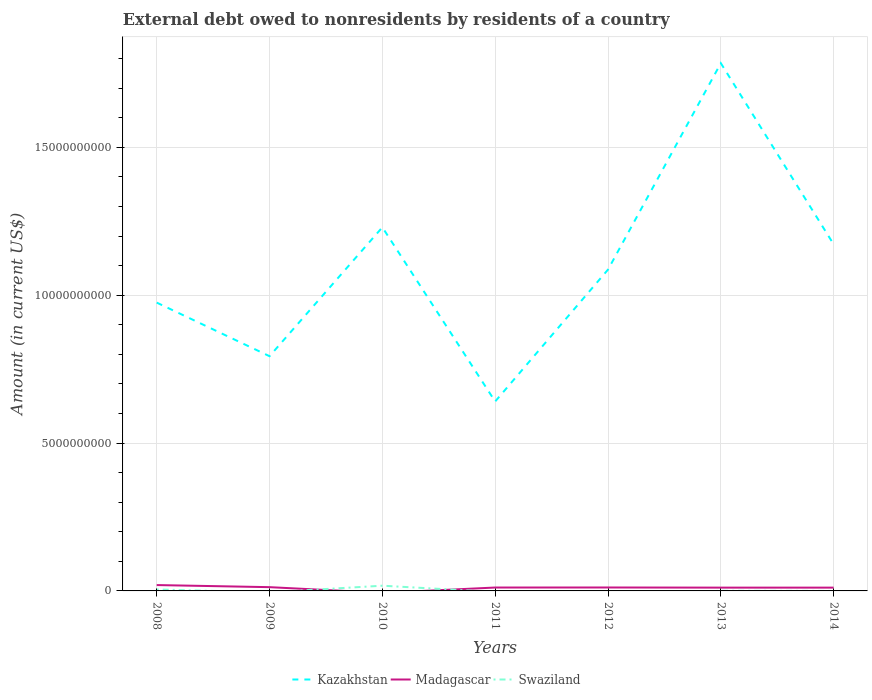Is the number of lines equal to the number of legend labels?
Give a very brief answer. No. Across all years, what is the maximum external debt owed by residents in Swaziland?
Make the answer very short. 0. What is the total external debt owed by residents in Kazakhstan in the graph?
Provide a short and direct response. -2.55e+09. What is the difference between the highest and the second highest external debt owed by residents in Madagascar?
Your response must be concise. 1.98e+08. Is the external debt owed by residents in Madagascar strictly greater than the external debt owed by residents in Kazakhstan over the years?
Your answer should be compact. Yes. How many lines are there?
Make the answer very short. 3. How many years are there in the graph?
Offer a very short reply. 7. Does the graph contain grids?
Your answer should be very brief. Yes. Where does the legend appear in the graph?
Provide a short and direct response. Bottom center. How many legend labels are there?
Your answer should be compact. 3. What is the title of the graph?
Make the answer very short. External debt owed to nonresidents by residents of a country. Does "Central African Republic" appear as one of the legend labels in the graph?
Offer a terse response. No. What is the label or title of the Y-axis?
Provide a succinct answer. Amount (in current US$). What is the Amount (in current US$) in Kazakhstan in 2008?
Give a very brief answer. 9.75e+09. What is the Amount (in current US$) in Madagascar in 2008?
Make the answer very short. 1.98e+08. What is the Amount (in current US$) of Swaziland in 2008?
Offer a very short reply. 4.91e+07. What is the Amount (in current US$) in Kazakhstan in 2009?
Ensure brevity in your answer.  7.94e+09. What is the Amount (in current US$) of Madagascar in 2009?
Your answer should be very brief. 1.27e+08. What is the Amount (in current US$) of Swaziland in 2009?
Your answer should be very brief. 0. What is the Amount (in current US$) of Kazakhstan in 2010?
Provide a short and direct response. 1.23e+1. What is the Amount (in current US$) of Madagascar in 2010?
Your answer should be compact. 0. What is the Amount (in current US$) in Swaziland in 2010?
Make the answer very short. 1.77e+08. What is the Amount (in current US$) of Kazakhstan in 2011?
Offer a very short reply. 6.41e+09. What is the Amount (in current US$) of Madagascar in 2011?
Your answer should be compact. 1.15e+08. What is the Amount (in current US$) of Swaziland in 2011?
Give a very brief answer. 0. What is the Amount (in current US$) of Kazakhstan in 2012?
Your answer should be compact. 1.09e+1. What is the Amount (in current US$) in Madagascar in 2012?
Ensure brevity in your answer.  1.16e+08. What is the Amount (in current US$) in Swaziland in 2012?
Offer a very short reply. 0. What is the Amount (in current US$) in Kazakhstan in 2013?
Offer a terse response. 1.78e+1. What is the Amount (in current US$) in Madagascar in 2013?
Your answer should be compact. 1.12e+08. What is the Amount (in current US$) in Swaziland in 2013?
Offer a very short reply. 4.84e+06. What is the Amount (in current US$) in Kazakhstan in 2014?
Keep it short and to the point. 1.17e+1. What is the Amount (in current US$) in Madagascar in 2014?
Provide a short and direct response. 1.12e+08. What is the Amount (in current US$) of Swaziland in 2014?
Give a very brief answer. 0. Across all years, what is the maximum Amount (in current US$) in Kazakhstan?
Offer a very short reply. 1.78e+1. Across all years, what is the maximum Amount (in current US$) of Madagascar?
Provide a short and direct response. 1.98e+08. Across all years, what is the maximum Amount (in current US$) of Swaziland?
Your response must be concise. 1.77e+08. Across all years, what is the minimum Amount (in current US$) in Kazakhstan?
Ensure brevity in your answer.  6.41e+09. Across all years, what is the minimum Amount (in current US$) in Madagascar?
Provide a succinct answer. 0. What is the total Amount (in current US$) of Kazakhstan in the graph?
Offer a terse response. 7.68e+1. What is the total Amount (in current US$) in Madagascar in the graph?
Keep it short and to the point. 7.80e+08. What is the total Amount (in current US$) of Swaziland in the graph?
Offer a very short reply. 2.31e+08. What is the difference between the Amount (in current US$) in Kazakhstan in 2008 and that in 2009?
Your answer should be very brief. 1.81e+09. What is the difference between the Amount (in current US$) of Madagascar in 2008 and that in 2009?
Provide a short and direct response. 7.08e+07. What is the difference between the Amount (in current US$) in Kazakhstan in 2008 and that in 2010?
Your answer should be very brief. -2.55e+09. What is the difference between the Amount (in current US$) of Swaziland in 2008 and that in 2010?
Your answer should be compact. -1.28e+08. What is the difference between the Amount (in current US$) in Kazakhstan in 2008 and that in 2011?
Offer a terse response. 3.34e+09. What is the difference between the Amount (in current US$) of Madagascar in 2008 and that in 2011?
Give a very brief answer. 8.37e+07. What is the difference between the Amount (in current US$) in Kazakhstan in 2008 and that in 2012?
Keep it short and to the point. -1.12e+09. What is the difference between the Amount (in current US$) of Madagascar in 2008 and that in 2012?
Provide a short and direct response. 8.20e+07. What is the difference between the Amount (in current US$) of Kazakhstan in 2008 and that in 2013?
Provide a short and direct response. -8.09e+09. What is the difference between the Amount (in current US$) in Madagascar in 2008 and that in 2013?
Your response must be concise. 8.67e+07. What is the difference between the Amount (in current US$) in Swaziland in 2008 and that in 2013?
Provide a succinct answer. 4.43e+07. What is the difference between the Amount (in current US$) in Kazakhstan in 2008 and that in 2014?
Keep it short and to the point. -1.97e+09. What is the difference between the Amount (in current US$) of Madagascar in 2008 and that in 2014?
Offer a very short reply. 8.66e+07. What is the difference between the Amount (in current US$) of Kazakhstan in 2009 and that in 2010?
Your answer should be compact. -4.36e+09. What is the difference between the Amount (in current US$) in Kazakhstan in 2009 and that in 2011?
Make the answer very short. 1.53e+09. What is the difference between the Amount (in current US$) in Madagascar in 2009 and that in 2011?
Ensure brevity in your answer.  1.29e+07. What is the difference between the Amount (in current US$) in Kazakhstan in 2009 and that in 2012?
Your answer should be very brief. -2.93e+09. What is the difference between the Amount (in current US$) in Madagascar in 2009 and that in 2012?
Give a very brief answer. 1.12e+07. What is the difference between the Amount (in current US$) in Kazakhstan in 2009 and that in 2013?
Make the answer very short. -9.91e+09. What is the difference between the Amount (in current US$) in Madagascar in 2009 and that in 2013?
Provide a short and direct response. 1.59e+07. What is the difference between the Amount (in current US$) of Kazakhstan in 2009 and that in 2014?
Provide a succinct answer. -3.78e+09. What is the difference between the Amount (in current US$) of Madagascar in 2009 and that in 2014?
Provide a short and direct response. 1.58e+07. What is the difference between the Amount (in current US$) of Kazakhstan in 2010 and that in 2011?
Offer a terse response. 5.89e+09. What is the difference between the Amount (in current US$) of Kazakhstan in 2010 and that in 2012?
Keep it short and to the point. 1.43e+09. What is the difference between the Amount (in current US$) in Kazakhstan in 2010 and that in 2013?
Give a very brief answer. -5.55e+09. What is the difference between the Amount (in current US$) in Swaziland in 2010 and that in 2013?
Give a very brief answer. 1.72e+08. What is the difference between the Amount (in current US$) of Kazakhstan in 2010 and that in 2014?
Provide a short and direct response. 5.75e+08. What is the difference between the Amount (in current US$) in Kazakhstan in 2011 and that in 2012?
Keep it short and to the point. -4.46e+09. What is the difference between the Amount (in current US$) in Madagascar in 2011 and that in 2012?
Make the answer very short. -1.68e+06. What is the difference between the Amount (in current US$) in Kazakhstan in 2011 and that in 2013?
Your answer should be compact. -1.14e+1. What is the difference between the Amount (in current US$) in Madagascar in 2011 and that in 2013?
Your answer should be compact. 2.99e+06. What is the difference between the Amount (in current US$) of Kazakhstan in 2011 and that in 2014?
Give a very brief answer. -5.31e+09. What is the difference between the Amount (in current US$) of Madagascar in 2011 and that in 2014?
Give a very brief answer. 2.89e+06. What is the difference between the Amount (in current US$) of Kazakhstan in 2012 and that in 2013?
Your response must be concise. -6.98e+09. What is the difference between the Amount (in current US$) in Madagascar in 2012 and that in 2013?
Your answer should be very brief. 4.67e+06. What is the difference between the Amount (in current US$) in Kazakhstan in 2012 and that in 2014?
Provide a succinct answer. -8.55e+08. What is the difference between the Amount (in current US$) in Madagascar in 2012 and that in 2014?
Your answer should be compact. 4.57e+06. What is the difference between the Amount (in current US$) of Kazakhstan in 2013 and that in 2014?
Make the answer very short. 6.12e+09. What is the difference between the Amount (in current US$) of Madagascar in 2013 and that in 2014?
Offer a terse response. -9.90e+04. What is the difference between the Amount (in current US$) of Kazakhstan in 2008 and the Amount (in current US$) of Madagascar in 2009?
Your response must be concise. 9.62e+09. What is the difference between the Amount (in current US$) in Kazakhstan in 2008 and the Amount (in current US$) in Swaziland in 2010?
Keep it short and to the point. 9.57e+09. What is the difference between the Amount (in current US$) in Madagascar in 2008 and the Amount (in current US$) in Swaziland in 2010?
Offer a terse response. 2.16e+07. What is the difference between the Amount (in current US$) of Kazakhstan in 2008 and the Amount (in current US$) of Madagascar in 2011?
Your response must be concise. 9.63e+09. What is the difference between the Amount (in current US$) of Kazakhstan in 2008 and the Amount (in current US$) of Madagascar in 2012?
Your response must be concise. 9.63e+09. What is the difference between the Amount (in current US$) in Kazakhstan in 2008 and the Amount (in current US$) in Madagascar in 2013?
Keep it short and to the point. 9.64e+09. What is the difference between the Amount (in current US$) of Kazakhstan in 2008 and the Amount (in current US$) of Swaziland in 2013?
Give a very brief answer. 9.74e+09. What is the difference between the Amount (in current US$) of Madagascar in 2008 and the Amount (in current US$) of Swaziland in 2013?
Provide a succinct answer. 1.93e+08. What is the difference between the Amount (in current US$) in Kazakhstan in 2008 and the Amount (in current US$) in Madagascar in 2014?
Provide a short and direct response. 9.64e+09. What is the difference between the Amount (in current US$) of Kazakhstan in 2009 and the Amount (in current US$) of Swaziland in 2010?
Make the answer very short. 7.76e+09. What is the difference between the Amount (in current US$) of Madagascar in 2009 and the Amount (in current US$) of Swaziland in 2010?
Offer a very short reply. -4.92e+07. What is the difference between the Amount (in current US$) of Kazakhstan in 2009 and the Amount (in current US$) of Madagascar in 2011?
Offer a terse response. 7.82e+09. What is the difference between the Amount (in current US$) of Kazakhstan in 2009 and the Amount (in current US$) of Madagascar in 2012?
Your response must be concise. 7.82e+09. What is the difference between the Amount (in current US$) in Kazakhstan in 2009 and the Amount (in current US$) in Madagascar in 2013?
Give a very brief answer. 7.83e+09. What is the difference between the Amount (in current US$) in Kazakhstan in 2009 and the Amount (in current US$) in Swaziland in 2013?
Make the answer very short. 7.93e+09. What is the difference between the Amount (in current US$) in Madagascar in 2009 and the Amount (in current US$) in Swaziland in 2013?
Offer a terse response. 1.23e+08. What is the difference between the Amount (in current US$) in Kazakhstan in 2009 and the Amount (in current US$) in Madagascar in 2014?
Give a very brief answer. 7.82e+09. What is the difference between the Amount (in current US$) of Kazakhstan in 2010 and the Amount (in current US$) of Madagascar in 2011?
Give a very brief answer. 1.22e+1. What is the difference between the Amount (in current US$) in Kazakhstan in 2010 and the Amount (in current US$) in Madagascar in 2012?
Offer a very short reply. 1.22e+1. What is the difference between the Amount (in current US$) in Kazakhstan in 2010 and the Amount (in current US$) in Madagascar in 2013?
Give a very brief answer. 1.22e+1. What is the difference between the Amount (in current US$) of Kazakhstan in 2010 and the Amount (in current US$) of Swaziland in 2013?
Provide a succinct answer. 1.23e+1. What is the difference between the Amount (in current US$) in Kazakhstan in 2010 and the Amount (in current US$) in Madagascar in 2014?
Offer a very short reply. 1.22e+1. What is the difference between the Amount (in current US$) in Kazakhstan in 2011 and the Amount (in current US$) in Madagascar in 2012?
Your answer should be compact. 6.29e+09. What is the difference between the Amount (in current US$) in Kazakhstan in 2011 and the Amount (in current US$) in Madagascar in 2013?
Your answer should be very brief. 6.29e+09. What is the difference between the Amount (in current US$) of Kazakhstan in 2011 and the Amount (in current US$) of Swaziland in 2013?
Provide a succinct answer. 6.40e+09. What is the difference between the Amount (in current US$) of Madagascar in 2011 and the Amount (in current US$) of Swaziland in 2013?
Your answer should be very brief. 1.10e+08. What is the difference between the Amount (in current US$) in Kazakhstan in 2011 and the Amount (in current US$) in Madagascar in 2014?
Provide a succinct answer. 6.29e+09. What is the difference between the Amount (in current US$) of Kazakhstan in 2012 and the Amount (in current US$) of Madagascar in 2013?
Your answer should be compact. 1.08e+1. What is the difference between the Amount (in current US$) in Kazakhstan in 2012 and the Amount (in current US$) in Swaziland in 2013?
Provide a succinct answer. 1.09e+1. What is the difference between the Amount (in current US$) in Madagascar in 2012 and the Amount (in current US$) in Swaziland in 2013?
Make the answer very short. 1.11e+08. What is the difference between the Amount (in current US$) in Kazakhstan in 2012 and the Amount (in current US$) in Madagascar in 2014?
Provide a short and direct response. 1.08e+1. What is the difference between the Amount (in current US$) of Kazakhstan in 2013 and the Amount (in current US$) of Madagascar in 2014?
Make the answer very short. 1.77e+1. What is the average Amount (in current US$) in Kazakhstan per year?
Offer a terse response. 1.10e+1. What is the average Amount (in current US$) in Madagascar per year?
Your answer should be compact. 1.11e+08. What is the average Amount (in current US$) in Swaziland per year?
Keep it short and to the point. 3.29e+07. In the year 2008, what is the difference between the Amount (in current US$) in Kazakhstan and Amount (in current US$) in Madagascar?
Offer a very short reply. 9.55e+09. In the year 2008, what is the difference between the Amount (in current US$) in Kazakhstan and Amount (in current US$) in Swaziland?
Make the answer very short. 9.70e+09. In the year 2008, what is the difference between the Amount (in current US$) in Madagascar and Amount (in current US$) in Swaziland?
Your answer should be compact. 1.49e+08. In the year 2009, what is the difference between the Amount (in current US$) of Kazakhstan and Amount (in current US$) of Madagascar?
Offer a terse response. 7.81e+09. In the year 2010, what is the difference between the Amount (in current US$) of Kazakhstan and Amount (in current US$) of Swaziland?
Your response must be concise. 1.21e+1. In the year 2011, what is the difference between the Amount (in current US$) of Kazakhstan and Amount (in current US$) of Madagascar?
Provide a succinct answer. 6.29e+09. In the year 2012, what is the difference between the Amount (in current US$) of Kazakhstan and Amount (in current US$) of Madagascar?
Your response must be concise. 1.07e+1. In the year 2013, what is the difference between the Amount (in current US$) of Kazakhstan and Amount (in current US$) of Madagascar?
Offer a terse response. 1.77e+1. In the year 2013, what is the difference between the Amount (in current US$) of Kazakhstan and Amount (in current US$) of Swaziland?
Offer a very short reply. 1.78e+1. In the year 2013, what is the difference between the Amount (in current US$) in Madagascar and Amount (in current US$) in Swaziland?
Your answer should be compact. 1.07e+08. In the year 2014, what is the difference between the Amount (in current US$) of Kazakhstan and Amount (in current US$) of Madagascar?
Your response must be concise. 1.16e+1. What is the ratio of the Amount (in current US$) of Kazakhstan in 2008 to that in 2009?
Your answer should be very brief. 1.23. What is the ratio of the Amount (in current US$) in Madagascar in 2008 to that in 2009?
Keep it short and to the point. 1.56. What is the ratio of the Amount (in current US$) in Kazakhstan in 2008 to that in 2010?
Offer a very short reply. 0.79. What is the ratio of the Amount (in current US$) in Swaziland in 2008 to that in 2010?
Your answer should be compact. 0.28. What is the ratio of the Amount (in current US$) in Kazakhstan in 2008 to that in 2011?
Your answer should be compact. 1.52. What is the ratio of the Amount (in current US$) in Madagascar in 2008 to that in 2011?
Ensure brevity in your answer.  1.73. What is the ratio of the Amount (in current US$) of Kazakhstan in 2008 to that in 2012?
Your answer should be compact. 0.9. What is the ratio of the Amount (in current US$) of Madagascar in 2008 to that in 2012?
Offer a very short reply. 1.71. What is the ratio of the Amount (in current US$) in Kazakhstan in 2008 to that in 2013?
Give a very brief answer. 0.55. What is the ratio of the Amount (in current US$) of Madagascar in 2008 to that in 2013?
Give a very brief answer. 1.78. What is the ratio of the Amount (in current US$) of Swaziland in 2008 to that in 2013?
Provide a succinct answer. 10.16. What is the ratio of the Amount (in current US$) in Kazakhstan in 2008 to that in 2014?
Make the answer very short. 0.83. What is the ratio of the Amount (in current US$) in Madagascar in 2008 to that in 2014?
Offer a very short reply. 1.78. What is the ratio of the Amount (in current US$) in Kazakhstan in 2009 to that in 2010?
Ensure brevity in your answer.  0.65. What is the ratio of the Amount (in current US$) in Kazakhstan in 2009 to that in 2011?
Your response must be concise. 1.24. What is the ratio of the Amount (in current US$) in Madagascar in 2009 to that in 2011?
Offer a terse response. 1.11. What is the ratio of the Amount (in current US$) of Kazakhstan in 2009 to that in 2012?
Make the answer very short. 0.73. What is the ratio of the Amount (in current US$) in Madagascar in 2009 to that in 2012?
Provide a short and direct response. 1.1. What is the ratio of the Amount (in current US$) of Kazakhstan in 2009 to that in 2013?
Keep it short and to the point. 0.44. What is the ratio of the Amount (in current US$) of Madagascar in 2009 to that in 2013?
Give a very brief answer. 1.14. What is the ratio of the Amount (in current US$) in Kazakhstan in 2009 to that in 2014?
Provide a short and direct response. 0.68. What is the ratio of the Amount (in current US$) in Madagascar in 2009 to that in 2014?
Your response must be concise. 1.14. What is the ratio of the Amount (in current US$) of Kazakhstan in 2010 to that in 2011?
Ensure brevity in your answer.  1.92. What is the ratio of the Amount (in current US$) of Kazakhstan in 2010 to that in 2012?
Offer a terse response. 1.13. What is the ratio of the Amount (in current US$) in Kazakhstan in 2010 to that in 2013?
Offer a terse response. 0.69. What is the ratio of the Amount (in current US$) of Swaziland in 2010 to that in 2013?
Your answer should be compact. 36.53. What is the ratio of the Amount (in current US$) in Kazakhstan in 2010 to that in 2014?
Provide a succinct answer. 1.05. What is the ratio of the Amount (in current US$) of Kazakhstan in 2011 to that in 2012?
Your response must be concise. 0.59. What is the ratio of the Amount (in current US$) of Madagascar in 2011 to that in 2012?
Your response must be concise. 0.99. What is the ratio of the Amount (in current US$) in Kazakhstan in 2011 to that in 2013?
Your answer should be compact. 0.36. What is the ratio of the Amount (in current US$) of Madagascar in 2011 to that in 2013?
Keep it short and to the point. 1.03. What is the ratio of the Amount (in current US$) in Kazakhstan in 2011 to that in 2014?
Your answer should be compact. 0.55. What is the ratio of the Amount (in current US$) in Madagascar in 2011 to that in 2014?
Provide a short and direct response. 1.03. What is the ratio of the Amount (in current US$) of Kazakhstan in 2012 to that in 2013?
Offer a very short reply. 0.61. What is the ratio of the Amount (in current US$) in Madagascar in 2012 to that in 2013?
Make the answer very short. 1.04. What is the ratio of the Amount (in current US$) in Kazakhstan in 2012 to that in 2014?
Your response must be concise. 0.93. What is the ratio of the Amount (in current US$) in Madagascar in 2012 to that in 2014?
Make the answer very short. 1.04. What is the ratio of the Amount (in current US$) of Kazakhstan in 2013 to that in 2014?
Make the answer very short. 1.52. What is the ratio of the Amount (in current US$) in Madagascar in 2013 to that in 2014?
Offer a very short reply. 1. What is the difference between the highest and the second highest Amount (in current US$) of Kazakhstan?
Your answer should be very brief. 5.55e+09. What is the difference between the highest and the second highest Amount (in current US$) in Madagascar?
Offer a terse response. 7.08e+07. What is the difference between the highest and the second highest Amount (in current US$) in Swaziland?
Offer a terse response. 1.28e+08. What is the difference between the highest and the lowest Amount (in current US$) of Kazakhstan?
Ensure brevity in your answer.  1.14e+1. What is the difference between the highest and the lowest Amount (in current US$) of Madagascar?
Offer a terse response. 1.98e+08. What is the difference between the highest and the lowest Amount (in current US$) of Swaziland?
Your response must be concise. 1.77e+08. 